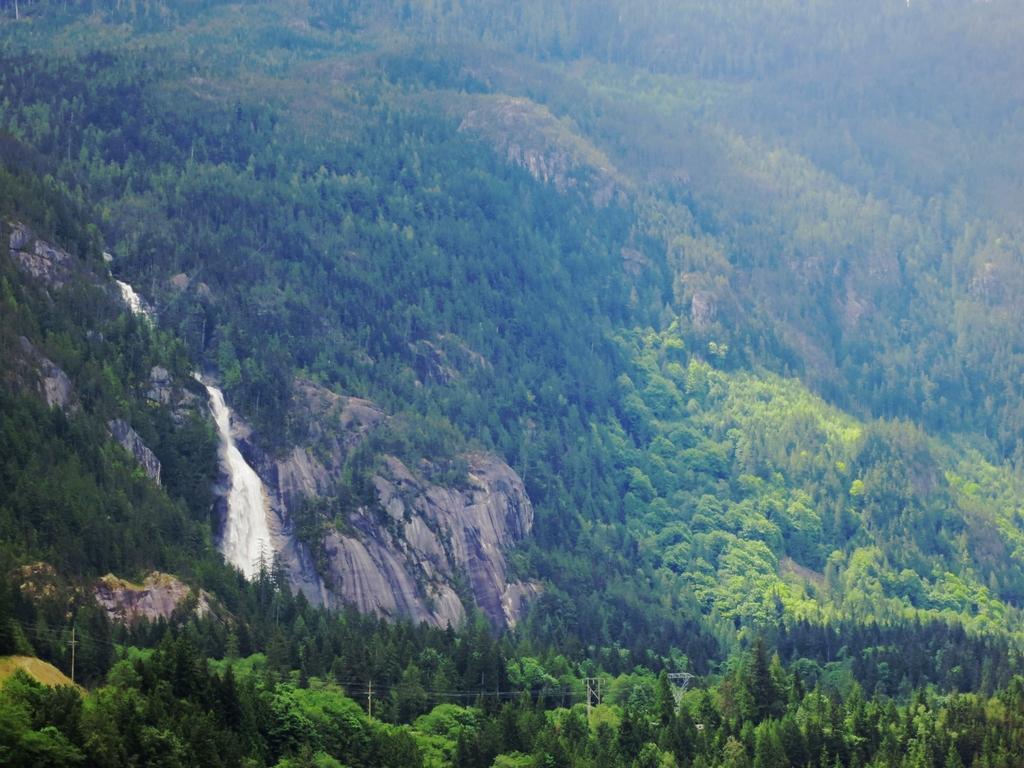Can you describe this image briefly? In this image, in the middle there are trees, hills, stones, water falls. 